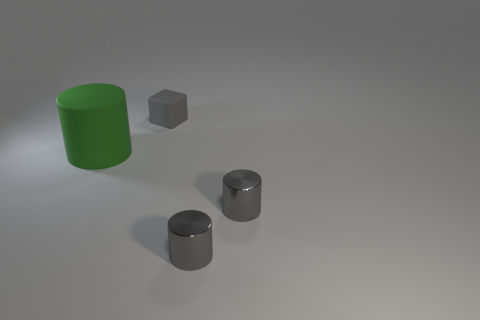Subtract all small shiny cylinders. How many cylinders are left? 1 Subtract all green cylinders. How many cylinders are left? 2 Add 1 tiny matte things. How many objects exist? 5 Subtract all cubes. How many objects are left? 3 Add 1 gray rubber objects. How many gray rubber objects are left? 2 Add 3 metallic cubes. How many metallic cubes exist? 3 Subtract 0 blue cylinders. How many objects are left? 4 Subtract all purple cubes. Subtract all green cylinders. How many cubes are left? 1 Subtract all yellow blocks. How many green cylinders are left? 1 Subtract all gray things. Subtract all green things. How many objects are left? 0 